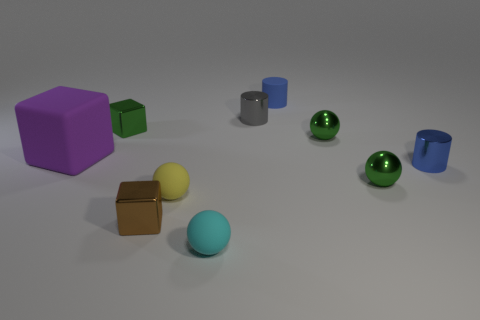Subtract all balls. How many objects are left? 6 Subtract all gray objects. Subtract all gray things. How many objects are left? 8 Add 9 big cubes. How many big cubes are left? 10 Add 6 purple metal cubes. How many purple metal cubes exist? 6 Subtract 1 gray cylinders. How many objects are left? 9 